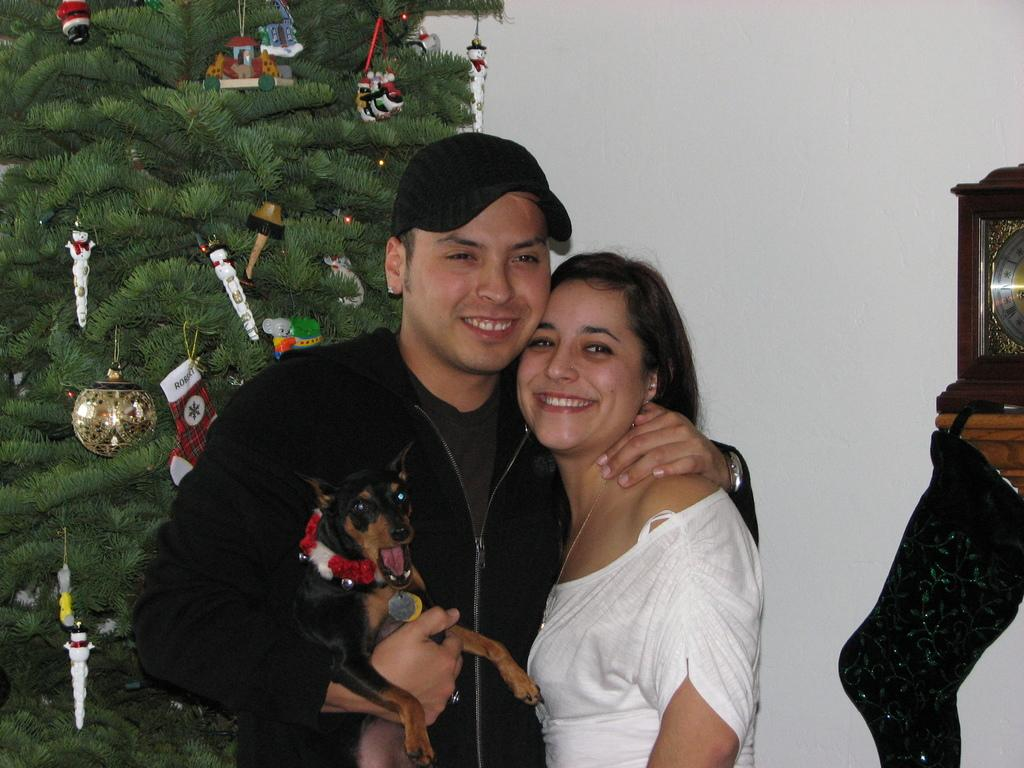Who is present in the image? There are two people, a woman and a man, in the image. What are the people doing in the image? The people are standing and smiling. What additional object can be seen in the image? There is a Christmas tree in the image. What type of net is being used to catch the fish in the image? There is no fish or net present in the image; it features a woman, a man, and a Christmas tree. 